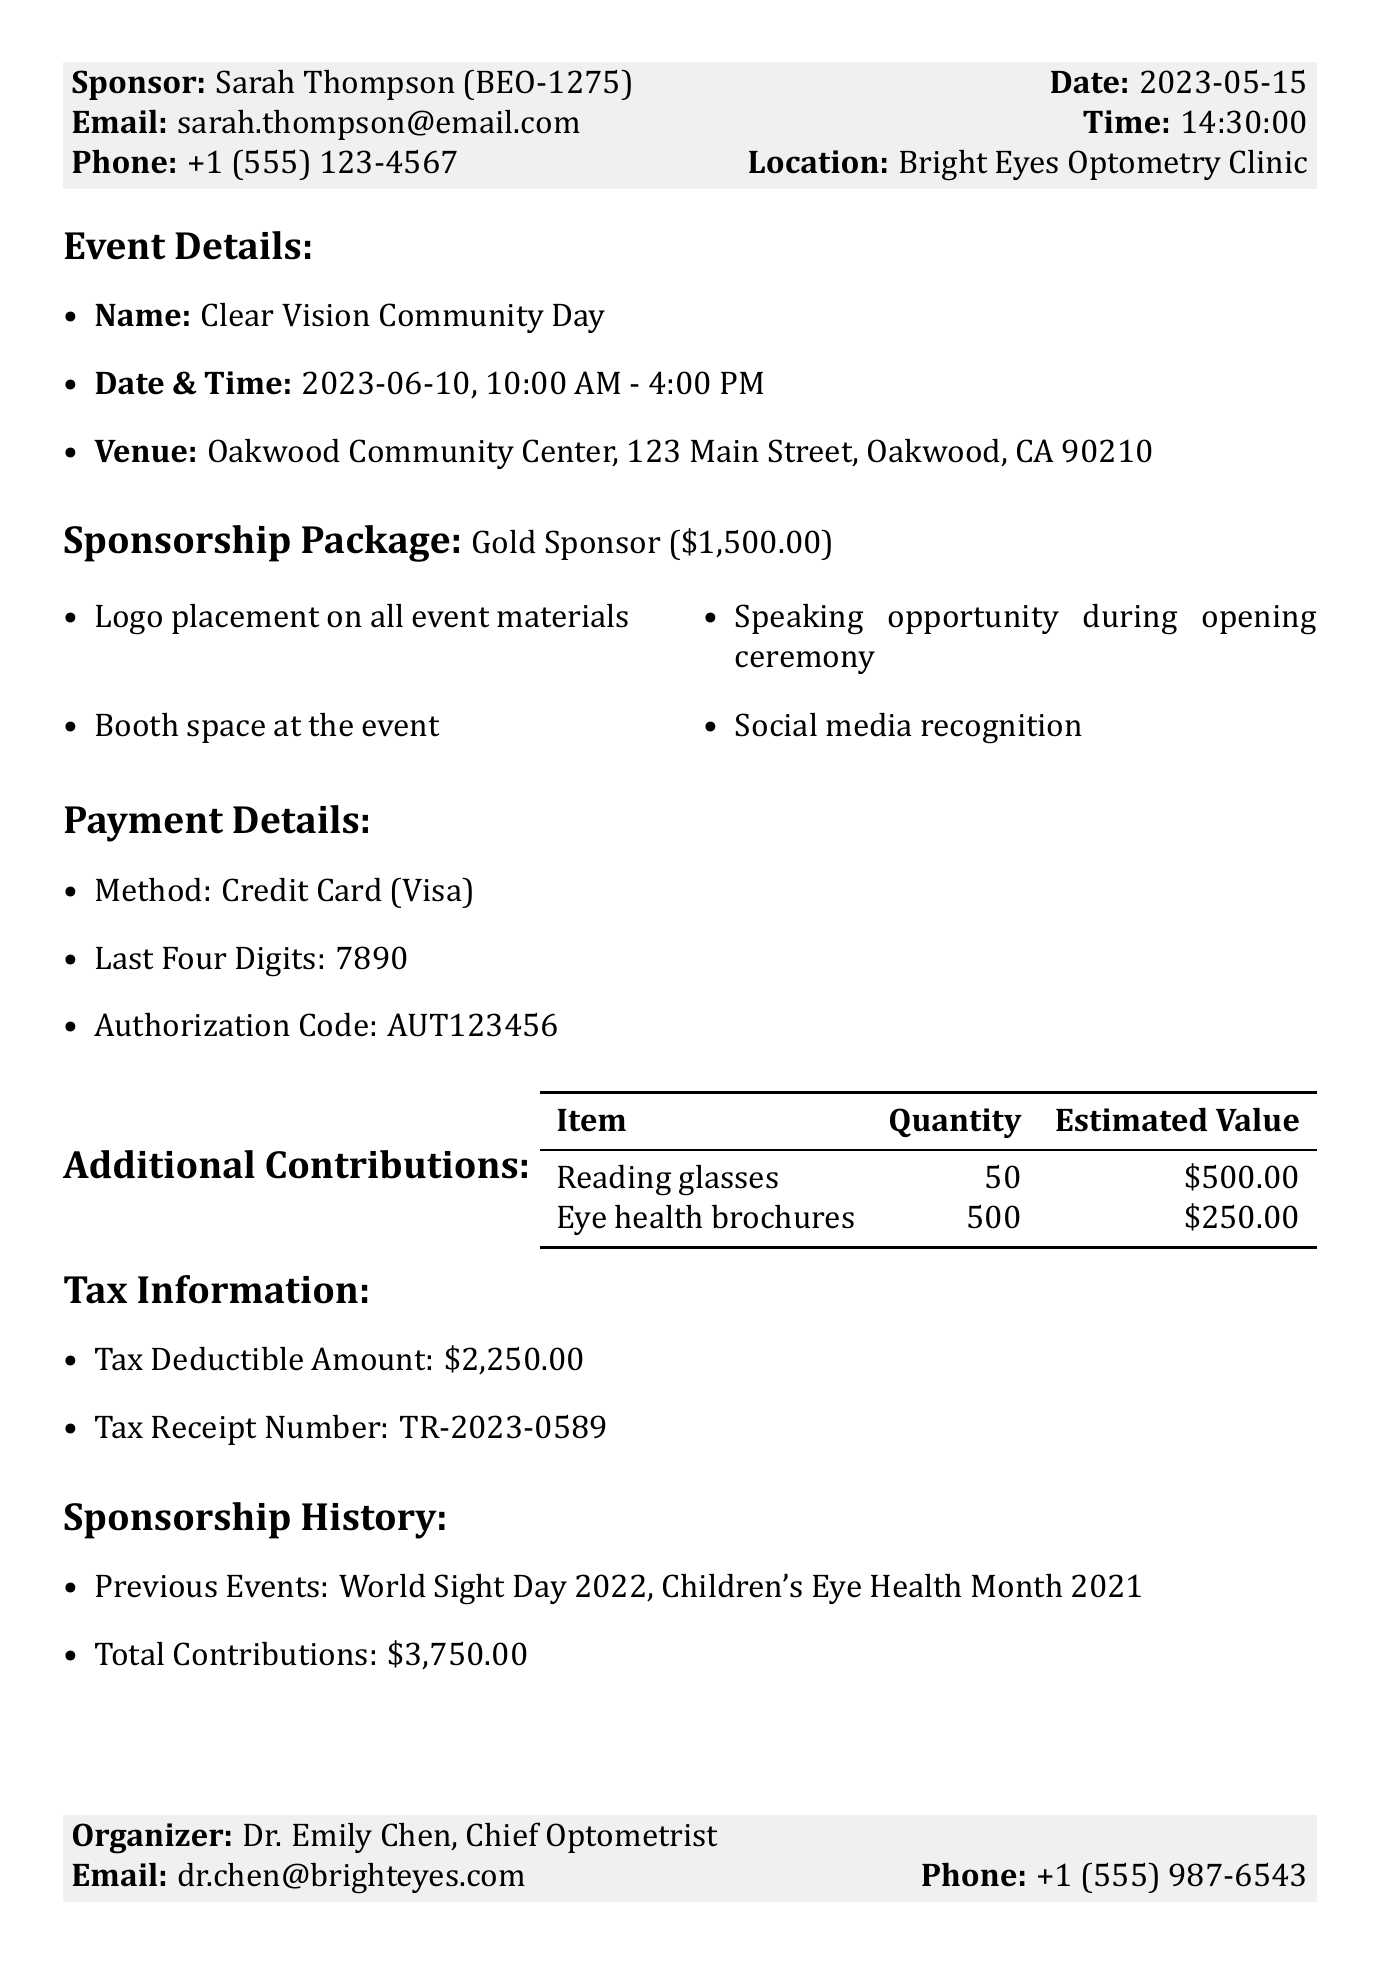What is the transaction ID? The transaction ID is listed at the top of the document, which is a unique identifier for the transaction.
Answer: EH-2023-0589 Who is the sponsor of the event? The sponsor's name is mentioned in the sponsor section of the document.
Answer: Sarah Thompson What is the event name? The event name can be found under the event details section.
Answer: Clear Vision Community Day When is the event scheduled? The event date is specified in the event details section.
Answer: 2023-06-10 What is the total sponsorship amount? The sponsorship amount is highlighted in the sponsorship package section.
Answer: $1,500.00 What are the estimated values of the donated items? The estimated values are provided next to each item listed in the additional contributions section.
Answer: $500.00 and $250.00 Who is the organizer of the event? The organizer's name and title are located in the organizer details section.
Answer: Dr. Emily Chen What is the tax deductible amount? The tax deductible amount is specified in the tax information section of the document.
Answer: $2,250.00 How many previous events has the sponsor contributed to? The previous events are listed under the sponsorship history section, from which we can count the number of events.
Answer: 2 